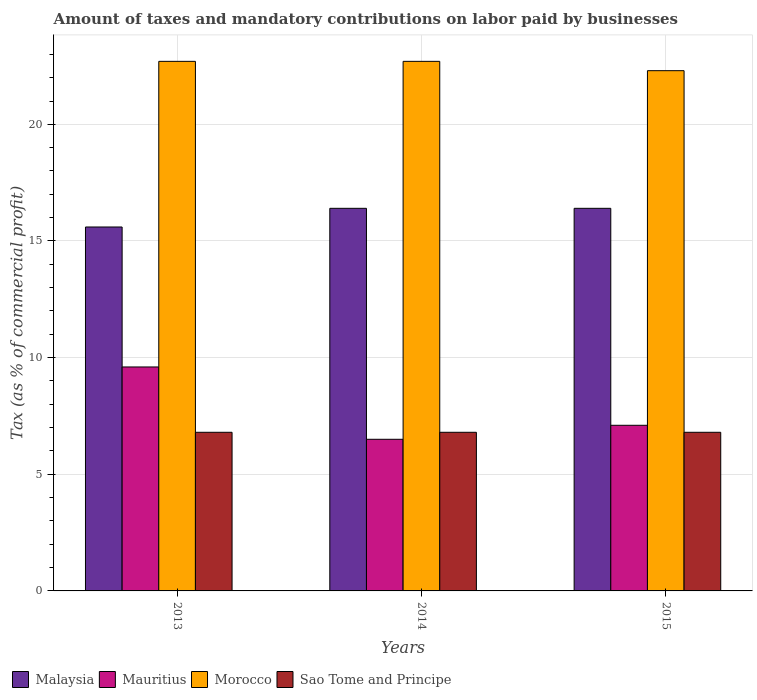How many different coloured bars are there?
Give a very brief answer. 4. How many groups of bars are there?
Ensure brevity in your answer.  3. Are the number of bars on each tick of the X-axis equal?
Your answer should be very brief. Yes. How many bars are there on the 2nd tick from the left?
Ensure brevity in your answer.  4. What is the percentage of taxes paid by businesses in Malaysia in 2015?
Keep it short and to the point. 16.4. Across all years, what is the maximum percentage of taxes paid by businesses in Sao Tome and Principe?
Give a very brief answer. 6.8. Across all years, what is the minimum percentage of taxes paid by businesses in Malaysia?
Offer a very short reply. 15.6. In which year was the percentage of taxes paid by businesses in Mauritius maximum?
Provide a short and direct response. 2013. What is the total percentage of taxes paid by businesses in Mauritius in the graph?
Offer a terse response. 23.2. What is the difference between the percentage of taxes paid by businesses in Sao Tome and Principe in 2013 and that in 2014?
Ensure brevity in your answer.  0. What is the difference between the percentage of taxes paid by businesses in Mauritius in 2015 and the percentage of taxes paid by businesses in Sao Tome and Principe in 2013?
Ensure brevity in your answer.  0.3. What is the average percentage of taxes paid by businesses in Malaysia per year?
Your answer should be very brief. 16.13. What is the ratio of the percentage of taxes paid by businesses in Morocco in 2014 to that in 2015?
Ensure brevity in your answer.  1.02. Is the percentage of taxes paid by businesses in Sao Tome and Principe in 2014 less than that in 2015?
Provide a short and direct response. No. Is the difference between the percentage of taxes paid by businesses in Sao Tome and Principe in 2014 and 2015 greater than the difference between the percentage of taxes paid by businesses in Malaysia in 2014 and 2015?
Make the answer very short. No. What is the difference between the highest and the second highest percentage of taxes paid by businesses in Malaysia?
Provide a succinct answer. 0. What is the difference between the highest and the lowest percentage of taxes paid by businesses in Malaysia?
Your answer should be compact. 0.8. Is the sum of the percentage of taxes paid by businesses in Malaysia in 2013 and 2014 greater than the maximum percentage of taxes paid by businesses in Mauritius across all years?
Give a very brief answer. Yes. What does the 1st bar from the left in 2013 represents?
Your answer should be compact. Malaysia. What does the 1st bar from the right in 2014 represents?
Provide a succinct answer. Sao Tome and Principe. Is it the case that in every year, the sum of the percentage of taxes paid by businesses in Mauritius and percentage of taxes paid by businesses in Sao Tome and Principe is greater than the percentage of taxes paid by businesses in Malaysia?
Your answer should be compact. No. How many bars are there?
Provide a short and direct response. 12. Are all the bars in the graph horizontal?
Provide a short and direct response. No. What is the difference between two consecutive major ticks on the Y-axis?
Ensure brevity in your answer.  5. Does the graph contain grids?
Your answer should be very brief. Yes. What is the title of the graph?
Offer a very short reply. Amount of taxes and mandatory contributions on labor paid by businesses. Does "Puerto Rico" appear as one of the legend labels in the graph?
Offer a very short reply. No. What is the label or title of the X-axis?
Your answer should be compact. Years. What is the label or title of the Y-axis?
Provide a short and direct response. Tax (as % of commercial profit). What is the Tax (as % of commercial profit) in Morocco in 2013?
Ensure brevity in your answer.  22.7. What is the Tax (as % of commercial profit) of Malaysia in 2014?
Keep it short and to the point. 16.4. What is the Tax (as % of commercial profit) in Mauritius in 2014?
Your response must be concise. 6.5. What is the Tax (as % of commercial profit) of Morocco in 2014?
Your answer should be very brief. 22.7. What is the Tax (as % of commercial profit) in Morocco in 2015?
Offer a terse response. 22.3. Across all years, what is the maximum Tax (as % of commercial profit) of Mauritius?
Provide a short and direct response. 9.6. Across all years, what is the maximum Tax (as % of commercial profit) in Morocco?
Provide a succinct answer. 22.7. Across all years, what is the minimum Tax (as % of commercial profit) in Malaysia?
Keep it short and to the point. 15.6. Across all years, what is the minimum Tax (as % of commercial profit) in Morocco?
Your answer should be compact. 22.3. Across all years, what is the minimum Tax (as % of commercial profit) in Sao Tome and Principe?
Your answer should be compact. 6.8. What is the total Tax (as % of commercial profit) of Malaysia in the graph?
Provide a succinct answer. 48.4. What is the total Tax (as % of commercial profit) of Mauritius in the graph?
Give a very brief answer. 23.2. What is the total Tax (as % of commercial profit) of Morocco in the graph?
Give a very brief answer. 67.7. What is the total Tax (as % of commercial profit) of Sao Tome and Principe in the graph?
Your answer should be compact. 20.4. What is the difference between the Tax (as % of commercial profit) in Malaysia in 2013 and that in 2014?
Ensure brevity in your answer.  -0.8. What is the difference between the Tax (as % of commercial profit) of Malaysia in 2013 and that in 2015?
Keep it short and to the point. -0.8. What is the difference between the Tax (as % of commercial profit) of Mauritius in 2014 and that in 2015?
Offer a very short reply. -0.6. What is the difference between the Tax (as % of commercial profit) in Malaysia in 2013 and the Tax (as % of commercial profit) in Morocco in 2014?
Your answer should be compact. -7.1. What is the difference between the Tax (as % of commercial profit) of Malaysia in 2013 and the Tax (as % of commercial profit) of Sao Tome and Principe in 2014?
Provide a short and direct response. 8.8. What is the difference between the Tax (as % of commercial profit) of Mauritius in 2013 and the Tax (as % of commercial profit) of Morocco in 2014?
Ensure brevity in your answer.  -13.1. What is the difference between the Tax (as % of commercial profit) of Mauritius in 2013 and the Tax (as % of commercial profit) of Sao Tome and Principe in 2014?
Your answer should be compact. 2.8. What is the difference between the Tax (as % of commercial profit) in Morocco in 2013 and the Tax (as % of commercial profit) in Sao Tome and Principe in 2014?
Your response must be concise. 15.9. What is the difference between the Tax (as % of commercial profit) in Malaysia in 2013 and the Tax (as % of commercial profit) in Morocco in 2015?
Offer a terse response. -6.7. What is the difference between the Tax (as % of commercial profit) in Malaysia in 2013 and the Tax (as % of commercial profit) in Sao Tome and Principe in 2015?
Make the answer very short. 8.8. What is the difference between the Tax (as % of commercial profit) in Mauritius in 2013 and the Tax (as % of commercial profit) in Morocco in 2015?
Your answer should be very brief. -12.7. What is the difference between the Tax (as % of commercial profit) in Mauritius in 2013 and the Tax (as % of commercial profit) in Sao Tome and Principe in 2015?
Offer a terse response. 2.8. What is the difference between the Tax (as % of commercial profit) of Morocco in 2013 and the Tax (as % of commercial profit) of Sao Tome and Principe in 2015?
Give a very brief answer. 15.9. What is the difference between the Tax (as % of commercial profit) of Mauritius in 2014 and the Tax (as % of commercial profit) of Morocco in 2015?
Provide a short and direct response. -15.8. What is the difference between the Tax (as % of commercial profit) of Morocco in 2014 and the Tax (as % of commercial profit) of Sao Tome and Principe in 2015?
Your answer should be compact. 15.9. What is the average Tax (as % of commercial profit) in Malaysia per year?
Keep it short and to the point. 16.13. What is the average Tax (as % of commercial profit) in Mauritius per year?
Ensure brevity in your answer.  7.73. What is the average Tax (as % of commercial profit) in Morocco per year?
Your response must be concise. 22.57. In the year 2013, what is the difference between the Tax (as % of commercial profit) in Malaysia and Tax (as % of commercial profit) in Morocco?
Offer a very short reply. -7.1. In the year 2013, what is the difference between the Tax (as % of commercial profit) in Malaysia and Tax (as % of commercial profit) in Sao Tome and Principe?
Make the answer very short. 8.8. In the year 2014, what is the difference between the Tax (as % of commercial profit) of Malaysia and Tax (as % of commercial profit) of Mauritius?
Your response must be concise. 9.9. In the year 2014, what is the difference between the Tax (as % of commercial profit) of Malaysia and Tax (as % of commercial profit) of Morocco?
Provide a short and direct response. -6.3. In the year 2014, what is the difference between the Tax (as % of commercial profit) of Mauritius and Tax (as % of commercial profit) of Morocco?
Ensure brevity in your answer.  -16.2. In the year 2014, what is the difference between the Tax (as % of commercial profit) in Mauritius and Tax (as % of commercial profit) in Sao Tome and Principe?
Offer a terse response. -0.3. In the year 2014, what is the difference between the Tax (as % of commercial profit) in Morocco and Tax (as % of commercial profit) in Sao Tome and Principe?
Provide a succinct answer. 15.9. In the year 2015, what is the difference between the Tax (as % of commercial profit) in Malaysia and Tax (as % of commercial profit) in Sao Tome and Principe?
Keep it short and to the point. 9.6. In the year 2015, what is the difference between the Tax (as % of commercial profit) in Mauritius and Tax (as % of commercial profit) in Morocco?
Provide a succinct answer. -15.2. In the year 2015, what is the difference between the Tax (as % of commercial profit) of Morocco and Tax (as % of commercial profit) of Sao Tome and Principe?
Give a very brief answer. 15.5. What is the ratio of the Tax (as % of commercial profit) of Malaysia in 2013 to that in 2014?
Your answer should be very brief. 0.95. What is the ratio of the Tax (as % of commercial profit) of Mauritius in 2013 to that in 2014?
Your answer should be very brief. 1.48. What is the ratio of the Tax (as % of commercial profit) of Sao Tome and Principe in 2013 to that in 2014?
Your answer should be compact. 1. What is the ratio of the Tax (as % of commercial profit) of Malaysia in 2013 to that in 2015?
Provide a succinct answer. 0.95. What is the ratio of the Tax (as % of commercial profit) of Mauritius in 2013 to that in 2015?
Your answer should be compact. 1.35. What is the ratio of the Tax (as % of commercial profit) in Morocco in 2013 to that in 2015?
Your answer should be compact. 1.02. What is the ratio of the Tax (as % of commercial profit) in Mauritius in 2014 to that in 2015?
Ensure brevity in your answer.  0.92. What is the ratio of the Tax (as % of commercial profit) of Morocco in 2014 to that in 2015?
Ensure brevity in your answer.  1.02. What is the difference between the highest and the second highest Tax (as % of commercial profit) of Mauritius?
Keep it short and to the point. 2.5. What is the difference between the highest and the second highest Tax (as % of commercial profit) in Sao Tome and Principe?
Offer a very short reply. 0. What is the difference between the highest and the lowest Tax (as % of commercial profit) of Malaysia?
Make the answer very short. 0.8. What is the difference between the highest and the lowest Tax (as % of commercial profit) in Mauritius?
Make the answer very short. 3.1. 